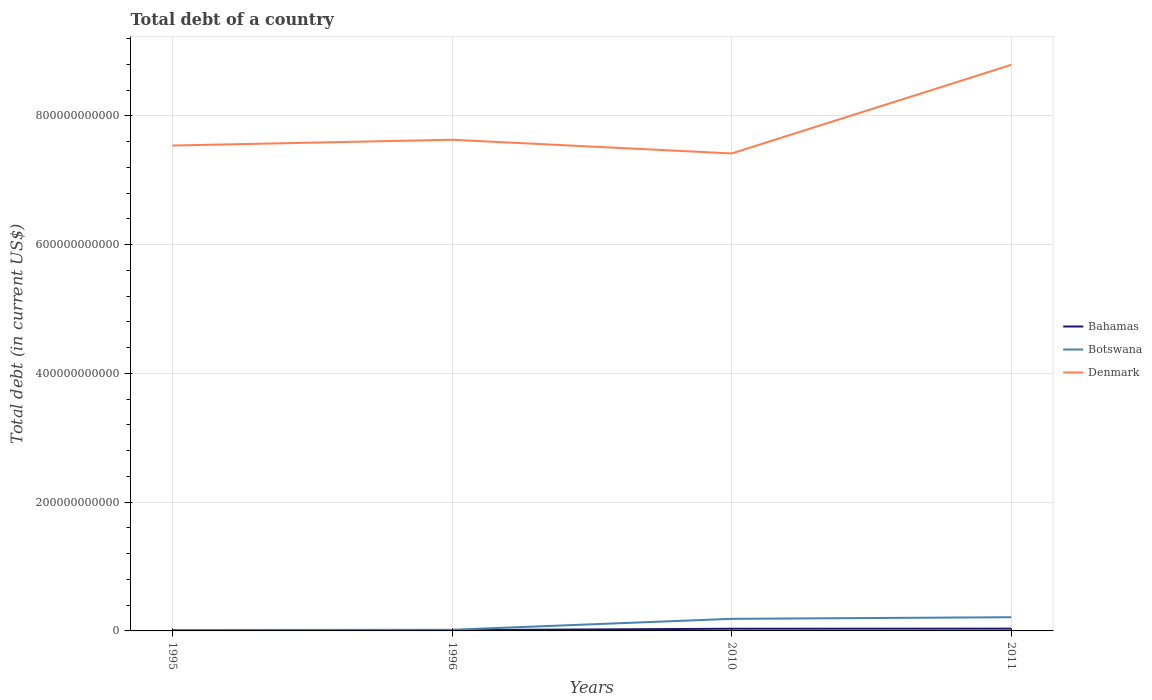Across all years, what is the maximum debt in Denmark?
Ensure brevity in your answer.  7.42e+11. In which year was the debt in Denmark maximum?
Your answer should be very brief. 2010. What is the total debt in Denmark in the graph?
Provide a short and direct response. -1.38e+11. What is the difference between the highest and the second highest debt in Bahamas?
Make the answer very short. 2.39e+09. Is the debt in Denmark strictly greater than the debt in Bahamas over the years?
Offer a terse response. No. What is the difference between two consecutive major ticks on the Y-axis?
Make the answer very short. 2.00e+11. Are the values on the major ticks of Y-axis written in scientific E-notation?
Ensure brevity in your answer.  No. Does the graph contain grids?
Keep it short and to the point. Yes. Where does the legend appear in the graph?
Give a very brief answer. Center right. How many legend labels are there?
Offer a terse response. 3. How are the legend labels stacked?
Ensure brevity in your answer.  Vertical. What is the title of the graph?
Your answer should be compact. Total debt of a country. Does "Benin" appear as one of the legend labels in the graph?
Your answer should be very brief. No. What is the label or title of the Y-axis?
Offer a terse response. Total debt (in current US$). What is the Total debt (in current US$) of Bahamas in 1995?
Your response must be concise. 1.17e+09. What is the Total debt (in current US$) of Botswana in 1995?
Your response must be concise. 1.44e+09. What is the Total debt (in current US$) in Denmark in 1995?
Offer a very short reply. 7.54e+11. What is the Total debt (in current US$) of Bahamas in 1996?
Keep it short and to the point. 1.24e+09. What is the Total debt (in current US$) in Botswana in 1996?
Make the answer very short. 1.80e+09. What is the Total debt (in current US$) in Denmark in 1996?
Ensure brevity in your answer.  7.63e+11. What is the Total debt (in current US$) of Bahamas in 2010?
Your response must be concise. 3.40e+09. What is the Total debt (in current US$) in Botswana in 2010?
Give a very brief answer. 1.88e+1. What is the Total debt (in current US$) of Denmark in 2010?
Offer a terse response. 7.42e+11. What is the Total debt (in current US$) in Bahamas in 2011?
Your answer should be very brief. 3.55e+09. What is the Total debt (in current US$) of Botswana in 2011?
Keep it short and to the point. 2.13e+1. What is the Total debt (in current US$) of Denmark in 2011?
Offer a terse response. 8.79e+11. Across all years, what is the maximum Total debt (in current US$) in Bahamas?
Offer a very short reply. 3.55e+09. Across all years, what is the maximum Total debt (in current US$) in Botswana?
Keep it short and to the point. 2.13e+1. Across all years, what is the maximum Total debt (in current US$) in Denmark?
Your response must be concise. 8.79e+11. Across all years, what is the minimum Total debt (in current US$) in Bahamas?
Provide a short and direct response. 1.17e+09. Across all years, what is the minimum Total debt (in current US$) in Botswana?
Make the answer very short. 1.44e+09. Across all years, what is the minimum Total debt (in current US$) of Denmark?
Ensure brevity in your answer.  7.42e+11. What is the total Total debt (in current US$) in Bahamas in the graph?
Make the answer very short. 9.35e+09. What is the total Total debt (in current US$) of Botswana in the graph?
Offer a terse response. 4.33e+1. What is the total Total debt (in current US$) in Denmark in the graph?
Ensure brevity in your answer.  3.14e+12. What is the difference between the Total debt (in current US$) of Bahamas in 1995 and that in 1996?
Offer a terse response. -6.93e+07. What is the difference between the Total debt (in current US$) of Botswana in 1995 and that in 1996?
Offer a very short reply. -3.59e+08. What is the difference between the Total debt (in current US$) of Denmark in 1995 and that in 1996?
Offer a terse response. -9.02e+09. What is the difference between the Total debt (in current US$) of Bahamas in 1995 and that in 2010?
Keep it short and to the point. -2.24e+09. What is the difference between the Total debt (in current US$) in Botswana in 1995 and that in 2010?
Make the answer very short. -1.74e+1. What is the difference between the Total debt (in current US$) in Denmark in 1995 and that in 2010?
Ensure brevity in your answer.  1.23e+1. What is the difference between the Total debt (in current US$) in Bahamas in 1995 and that in 2011?
Offer a very short reply. -2.39e+09. What is the difference between the Total debt (in current US$) in Botswana in 1995 and that in 2011?
Your response must be concise. -1.99e+1. What is the difference between the Total debt (in current US$) in Denmark in 1995 and that in 2011?
Make the answer very short. -1.25e+11. What is the difference between the Total debt (in current US$) of Bahamas in 1996 and that in 2010?
Provide a succinct answer. -2.17e+09. What is the difference between the Total debt (in current US$) in Botswana in 1996 and that in 2010?
Offer a terse response. -1.70e+1. What is the difference between the Total debt (in current US$) in Denmark in 1996 and that in 2010?
Offer a terse response. 2.13e+1. What is the difference between the Total debt (in current US$) in Bahamas in 1996 and that in 2011?
Ensure brevity in your answer.  -2.32e+09. What is the difference between the Total debt (in current US$) of Botswana in 1996 and that in 2011?
Provide a short and direct response. -1.95e+1. What is the difference between the Total debt (in current US$) in Denmark in 1996 and that in 2011?
Your response must be concise. -1.16e+11. What is the difference between the Total debt (in current US$) in Bahamas in 2010 and that in 2011?
Keep it short and to the point. -1.52e+08. What is the difference between the Total debt (in current US$) of Botswana in 2010 and that in 2011?
Make the answer very short. -2.51e+09. What is the difference between the Total debt (in current US$) of Denmark in 2010 and that in 2011?
Give a very brief answer. -1.38e+11. What is the difference between the Total debt (in current US$) in Bahamas in 1995 and the Total debt (in current US$) in Botswana in 1996?
Offer a terse response. -6.32e+08. What is the difference between the Total debt (in current US$) in Bahamas in 1995 and the Total debt (in current US$) in Denmark in 1996?
Your answer should be very brief. -7.62e+11. What is the difference between the Total debt (in current US$) of Botswana in 1995 and the Total debt (in current US$) of Denmark in 1996?
Provide a succinct answer. -7.62e+11. What is the difference between the Total debt (in current US$) of Bahamas in 1995 and the Total debt (in current US$) of Botswana in 2010?
Your answer should be compact. -1.76e+1. What is the difference between the Total debt (in current US$) of Bahamas in 1995 and the Total debt (in current US$) of Denmark in 2010?
Your answer should be compact. -7.41e+11. What is the difference between the Total debt (in current US$) of Botswana in 1995 and the Total debt (in current US$) of Denmark in 2010?
Provide a succinct answer. -7.40e+11. What is the difference between the Total debt (in current US$) in Bahamas in 1995 and the Total debt (in current US$) in Botswana in 2011?
Provide a short and direct response. -2.01e+1. What is the difference between the Total debt (in current US$) of Bahamas in 1995 and the Total debt (in current US$) of Denmark in 2011?
Offer a terse response. -8.78e+11. What is the difference between the Total debt (in current US$) in Botswana in 1995 and the Total debt (in current US$) in Denmark in 2011?
Give a very brief answer. -8.78e+11. What is the difference between the Total debt (in current US$) in Bahamas in 1996 and the Total debt (in current US$) in Botswana in 2010?
Your answer should be very brief. -1.76e+1. What is the difference between the Total debt (in current US$) of Bahamas in 1996 and the Total debt (in current US$) of Denmark in 2010?
Make the answer very short. -7.41e+11. What is the difference between the Total debt (in current US$) of Botswana in 1996 and the Total debt (in current US$) of Denmark in 2010?
Provide a short and direct response. -7.40e+11. What is the difference between the Total debt (in current US$) of Bahamas in 1996 and the Total debt (in current US$) of Botswana in 2011?
Ensure brevity in your answer.  -2.01e+1. What is the difference between the Total debt (in current US$) in Bahamas in 1996 and the Total debt (in current US$) in Denmark in 2011?
Your answer should be very brief. -8.78e+11. What is the difference between the Total debt (in current US$) of Botswana in 1996 and the Total debt (in current US$) of Denmark in 2011?
Offer a terse response. -8.78e+11. What is the difference between the Total debt (in current US$) in Bahamas in 2010 and the Total debt (in current US$) in Botswana in 2011?
Keep it short and to the point. -1.79e+1. What is the difference between the Total debt (in current US$) of Bahamas in 2010 and the Total debt (in current US$) of Denmark in 2011?
Provide a succinct answer. -8.76e+11. What is the difference between the Total debt (in current US$) of Botswana in 2010 and the Total debt (in current US$) of Denmark in 2011?
Your response must be concise. -8.61e+11. What is the average Total debt (in current US$) in Bahamas per year?
Provide a short and direct response. 2.34e+09. What is the average Total debt (in current US$) in Botswana per year?
Offer a very short reply. 1.08e+1. What is the average Total debt (in current US$) in Denmark per year?
Provide a succinct answer. 7.85e+11. In the year 1995, what is the difference between the Total debt (in current US$) of Bahamas and Total debt (in current US$) of Botswana?
Offer a very short reply. -2.73e+08. In the year 1995, what is the difference between the Total debt (in current US$) of Bahamas and Total debt (in current US$) of Denmark?
Keep it short and to the point. -7.53e+11. In the year 1995, what is the difference between the Total debt (in current US$) of Botswana and Total debt (in current US$) of Denmark?
Make the answer very short. -7.53e+11. In the year 1996, what is the difference between the Total debt (in current US$) of Bahamas and Total debt (in current US$) of Botswana?
Give a very brief answer. -5.63e+08. In the year 1996, what is the difference between the Total debt (in current US$) of Bahamas and Total debt (in current US$) of Denmark?
Your answer should be compact. -7.62e+11. In the year 1996, what is the difference between the Total debt (in current US$) of Botswana and Total debt (in current US$) of Denmark?
Your answer should be very brief. -7.61e+11. In the year 2010, what is the difference between the Total debt (in current US$) in Bahamas and Total debt (in current US$) in Botswana?
Ensure brevity in your answer.  -1.54e+1. In the year 2010, what is the difference between the Total debt (in current US$) of Bahamas and Total debt (in current US$) of Denmark?
Ensure brevity in your answer.  -7.38e+11. In the year 2010, what is the difference between the Total debt (in current US$) in Botswana and Total debt (in current US$) in Denmark?
Offer a very short reply. -7.23e+11. In the year 2011, what is the difference between the Total debt (in current US$) of Bahamas and Total debt (in current US$) of Botswana?
Offer a terse response. -1.77e+1. In the year 2011, what is the difference between the Total debt (in current US$) in Bahamas and Total debt (in current US$) in Denmark?
Your answer should be very brief. -8.76e+11. In the year 2011, what is the difference between the Total debt (in current US$) of Botswana and Total debt (in current US$) of Denmark?
Offer a terse response. -8.58e+11. What is the ratio of the Total debt (in current US$) of Bahamas in 1995 to that in 1996?
Offer a terse response. 0.94. What is the ratio of the Total debt (in current US$) in Botswana in 1995 to that in 1996?
Make the answer very short. 0.8. What is the ratio of the Total debt (in current US$) of Bahamas in 1995 to that in 2010?
Your answer should be very brief. 0.34. What is the ratio of the Total debt (in current US$) in Botswana in 1995 to that in 2010?
Ensure brevity in your answer.  0.08. What is the ratio of the Total debt (in current US$) in Denmark in 1995 to that in 2010?
Provide a succinct answer. 1.02. What is the ratio of the Total debt (in current US$) of Bahamas in 1995 to that in 2011?
Offer a terse response. 0.33. What is the ratio of the Total debt (in current US$) in Botswana in 1995 to that in 2011?
Keep it short and to the point. 0.07. What is the ratio of the Total debt (in current US$) in Denmark in 1995 to that in 2011?
Your response must be concise. 0.86. What is the ratio of the Total debt (in current US$) of Bahamas in 1996 to that in 2010?
Provide a short and direct response. 0.36. What is the ratio of the Total debt (in current US$) in Botswana in 1996 to that in 2010?
Keep it short and to the point. 0.1. What is the ratio of the Total debt (in current US$) of Denmark in 1996 to that in 2010?
Ensure brevity in your answer.  1.03. What is the ratio of the Total debt (in current US$) of Bahamas in 1996 to that in 2011?
Provide a succinct answer. 0.35. What is the ratio of the Total debt (in current US$) of Botswana in 1996 to that in 2011?
Ensure brevity in your answer.  0.08. What is the ratio of the Total debt (in current US$) in Denmark in 1996 to that in 2011?
Offer a terse response. 0.87. What is the ratio of the Total debt (in current US$) of Bahamas in 2010 to that in 2011?
Ensure brevity in your answer.  0.96. What is the ratio of the Total debt (in current US$) of Botswana in 2010 to that in 2011?
Ensure brevity in your answer.  0.88. What is the ratio of the Total debt (in current US$) of Denmark in 2010 to that in 2011?
Keep it short and to the point. 0.84. What is the difference between the highest and the second highest Total debt (in current US$) of Bahamas?
Your answer should be compact. 1.52e+08. What is the difference between the highest and the second highest Total debt (in current US$) in Botswana?
Offer a very short reply. 2.51e+09. What is the difference between the highest and the second highest Total debt (in current US$) of Denmark?
Make the answer very short. 1.16e+11. What is the difference between the highest and the lowest Total debt (in current US$) of Bahamas?
Your response must be concise. 2.39e+09. What is the difference between the highest and the lowest Total debt (in current US$) of Botswana?
Give a very brief answer. 1.99e+1. What is the difference between the highest and the lowest Total debt (in current US$) in Denmark?
Give a very brief answer. 1.38e+11. 